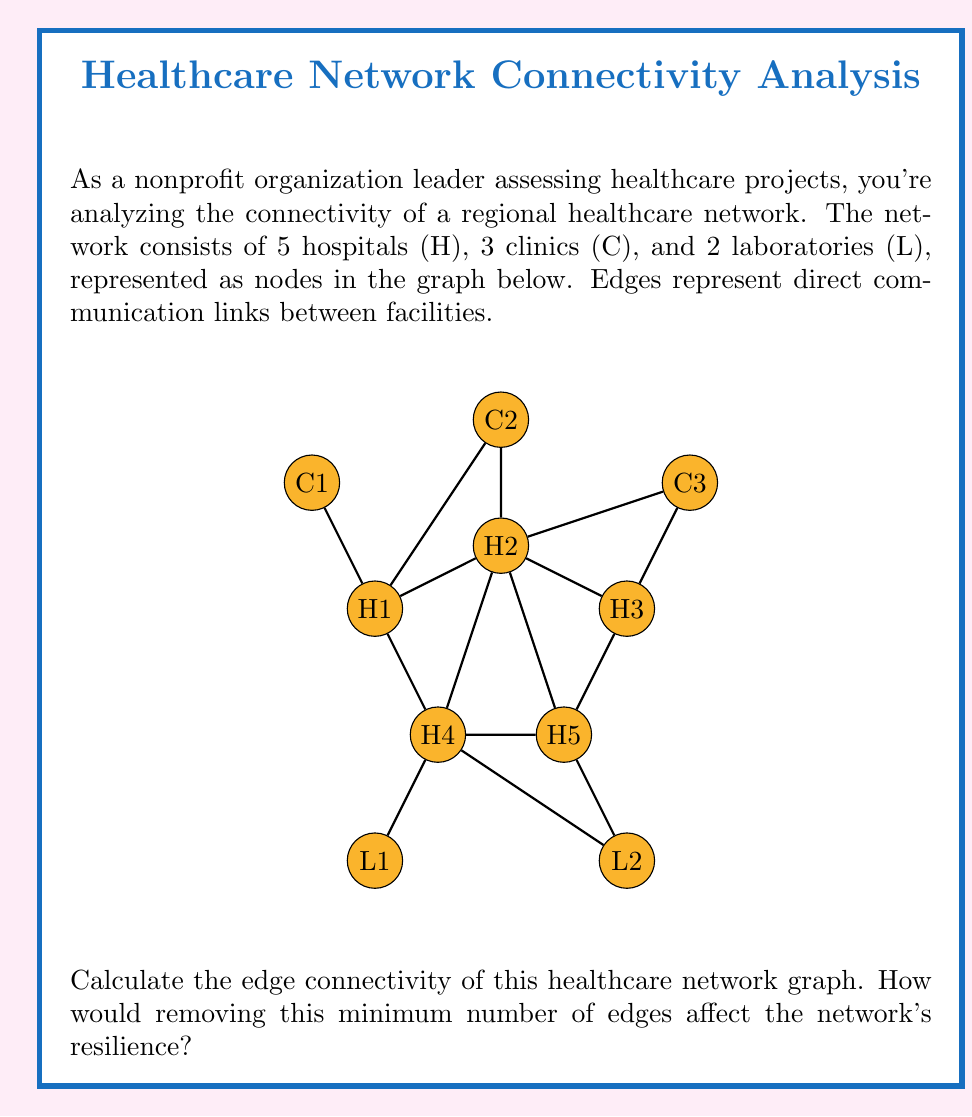Could you help me with this problem? To solve this problem, we need to understand the concept of edge connectivity in graph theory and apply it to the given healthcare network.

1. Edge Connectivity Definition:
   The edge connectivity of a graph, denoted as $\lambda(G)$, is the minimum number of edges that need to be removed to disconnect the graph.

2. Analyzing the Graph:
   - The graph has 10 nodes (5 hospitals, 3 clinics, 2 laboratories) and 13 edges.
   - We need to find the minimum cut set of edges that, if removed, would disconnect the graph.

3. Identifying Critical Connections:
   - Observe that the clinics (C1, C2, C3) are each connected to only one hospital.
   - The laboratories (L1, L2) are also connected to only one hospital each.
   - The hospitals form the core of the network, with multiple connections between them.

4. Finding the Minimum Cut:
   - Removing the edges H1-H3 and H2-H4 would disconnect the graph into two components.
   - This is the minimum number of edges needed to disconnect the graph.

5. Calculating Edge Connectivity:
   $\lambda(G) = 2$

6. Impact on Network Resilience:
   - With an edge connectivity of 2, the network is vulnerable to disconnection if two critical communication links fail.
   - This low connectivity indicates that the network has limited redundancy and backup paths for information flow.
   - Removing these two edges would split the network into two isolated components, severely impacting the ability of healthcare facilities to communicate and coordinate effectively.
Answer: $\lambda(G) = 2$; Low resilience due to potential network partition. 